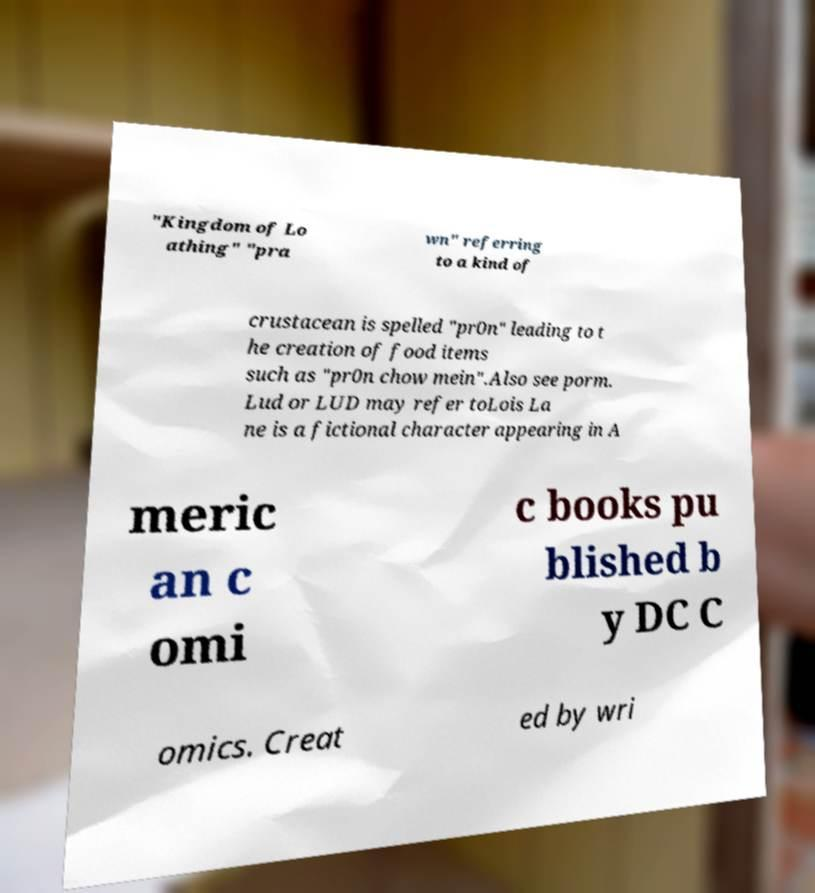For documentation purposes, I need the text within this image transcribed. Could you provide that? "Kingdom of Lo athing" "pra wn" referring to a kind of crustacean is spelled "pr0n" leading to t he creation of food items such as "pr0n chow mein".Also see porm. Lud or LUD may refer toLois La ne is a fictional character appearing in A meric an c omi c books pu blished b y DC C omics. Creat ed by wri 